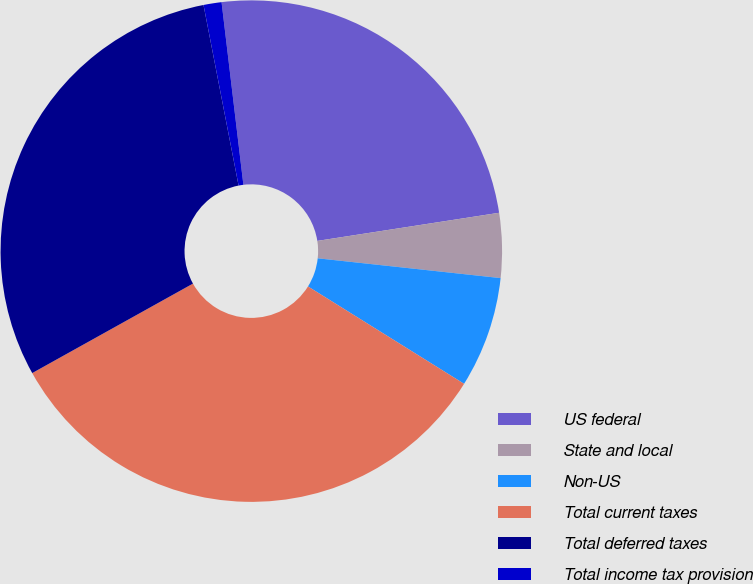<chart> <loc_0><loc_0><loc_500><loc_500><pie_chart><fcel>US federal<fcel>State and local<fcel>Non-US<fcel>Total current taxes<fcel>Total deferred taxes<fcel>Total income tax provision<nl><fcel>24.45%<fcel>4.16%<fcel>7.16%<fcel>33.04%<fcel>30.03%<fcel>1.16%<nl></chart> 